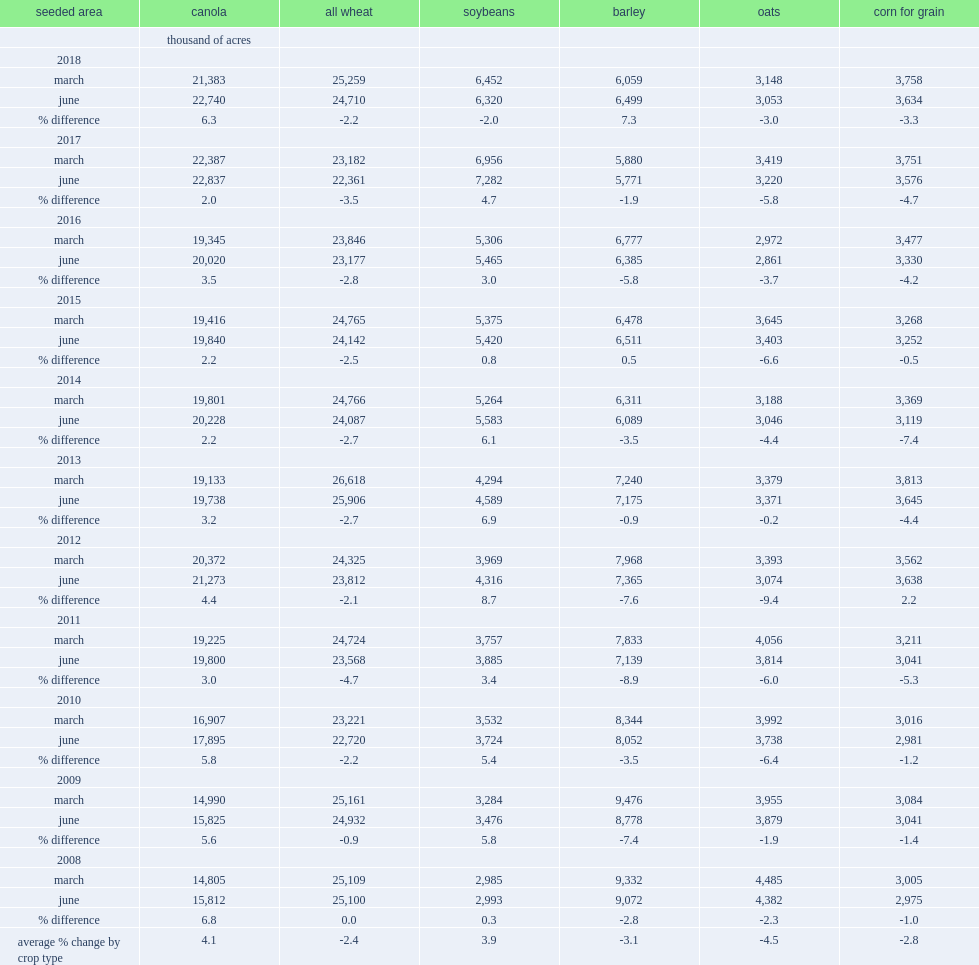What is the range of the average percentage difference at the national level in the preliminary acreage reports collected through the march farm survey for canada's major field crops from 2008 to 2017. -4.5 4.1. 